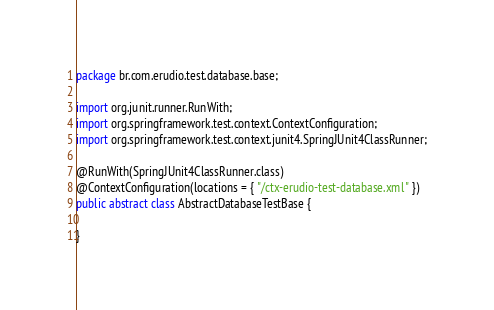<code> <loc_0><loc_0><loc_500><loc_500><_Java_>package br.com.erudio.test.database.base;

import org.junit.runner.RunWith;
import org.springframework.test.context.ContextConfiguration;
import org.springframework.test.context.junit4.SpringJUnit4ClassRunner;

@RunWith(SpringJUnit4ClassRunner.class)
@ContextConfiguration(locations = { "/ctx-erudio-test-database.xml" })
public abstract class AbstractDatabaseTestBase {

}
</code> 